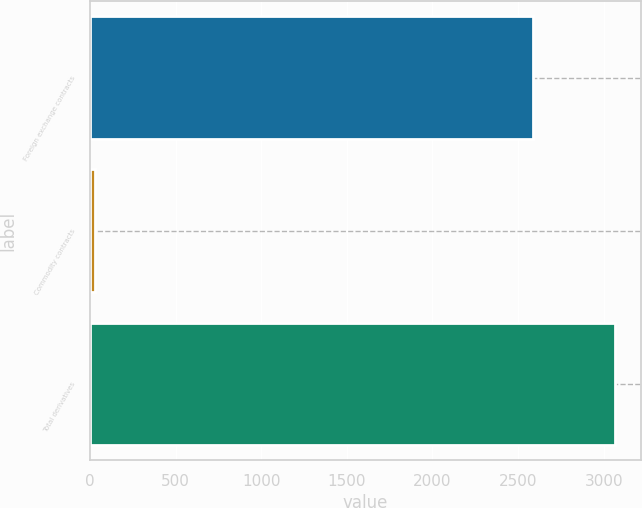Convert chart. <chart><loc_0><loc_0><loc_500><loc_500><bar_chart><fcel>Foreign exchange contracts<fcel>Commodity contracts<fcel>Total derivatives<nl><fcel>2586<fcel>31<fcel>3064<nl></chart> 